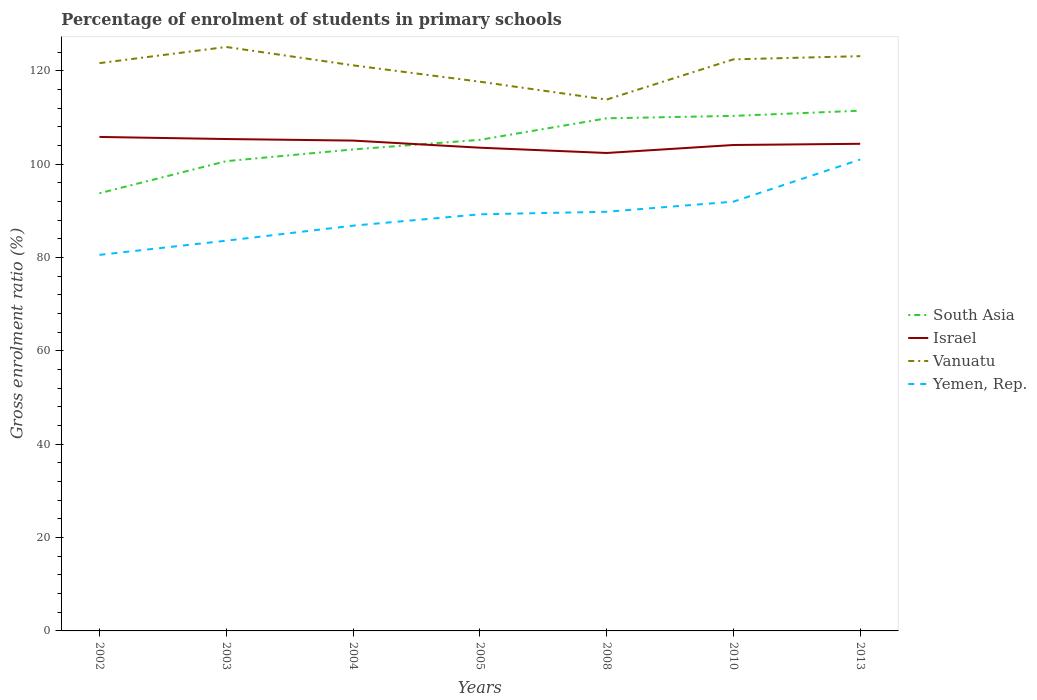Does the line corresponding to Yemen, Rep. intersect with the line corresponding to Israel?
Your answer should be very brief. No. Is the number of lines equal to the number of legend labels?
Your answer should be very brief. Yes. Across all years, what is the maximum percentage of students enrolled in primary schools in Israel?
Provide a short and direct response. 102.43. In which year was the percentage of students enrolled in primary schools in Yemen, Rep. maximum?
Ensure brevity in your answer.  2002. What is the total percentage of students enrolled in primary schools in Yemen, Rep. in the graph?
Provide a short and direct response. -9.03. What is the difference between the highest and the second highest percentage of students enrolled in primary schools in Israel?
Provide a short and direct response. 3.44. How many lines are there?
Keep it short and to the point. 4. What is the difference between two consecutive major ticks on the Y-axis?
Offer a very short reply. 20. Does the graph contain any zero values?
Offer a very short reply. No. Does the graph contain grids?
Provide a succinct answer. No. Where does the legend appear in the graph?
Keep it short and to the point. Center right. How many legend labels are there?
Your answer should be very brief. 4. How are the legend labels stacked?
Your answer should be very brief. Vertical. What is the title of the graph?
Ensure brevity in your answer.  Percentage of enrolment of students in primary schools. Does "Cameroon" appear as one of the legend labels in the graph?
Your response must be concise. No. What is the label or title of the Y-axis?
Keep it short and to the point. Gross enrolment ratio (%). What is the Gross enrolment ratio (%) of South Asia in 2002?
Give a very brief answer. 93.8. What is the Gross enrolment ratio (%) of Israel in 2002?
Offer a very short reply. 105.87. What is the Gross enrolment ratio (%) in Vanuatu in 2002?
Offer a very short reply. 121.68. What is the Gross enrolment ratio (%) of Yemen, Rep. in 2002?
Provide a succinct answer. 80.59. What is the Gross enrolment ratio (%) of South Asia in 2003?
Offer a very short reply. 100.68. What is the Gross enrolment ratio (%) in Israel in 2003?
Provide a short and direct response. 105.42. What is the Gross enrolment ratio (%) in Vanuatu in 2003?
Give a very brief answer. 125.15. What is the Gross enrolment ratio (%) of Yemen, Rep. in 2003?
Your response must be concise. 83.63. What is the Gross enrolment ratio (%) of South Asia in 2004?
Your answer should be very brief. 103.19. What is the Gross enrolment ratio (%) of Israel in 2004?
Provide a succinct answer. 105.09. What is the Gross enrolment ratio (%) of Vanuatu in 2004?
Provide a short and direct response. 121.22. What is the Gross enrolment ratio (%) in Yemen, Rep. in 2004?
Your answer should be very brief. 86.85. What is the Gross enrolment ratio (%) in South Asia in 2005?
Offer a terse response. 105.25. What is the Gross enrolment ratio (%) in Israel in 2005?
Offer a very short reply. 103.56. What is the Gross enrolment ratio (%) of Vanuatu in 2005?
Ensure brevity in your answer.  117.71. What is the Gross enrolment ratio (%) of Yemen, Rep. in 2005?
Provide a short and direct response. 89.29. What is the Gross enrolment ratio (%) of South Asia in 2008?
Provide a short and direct response. 109.86. What is the Gross enrolment ratio (%) in Israel in 2008?
Keep it short and to the point. 102.43. What is the Gross enrolment ratio (%) in Vanuatu in 2008?
Ensure brevity in your answer.  113.87. What is the Gross enrolment ratio (%) in Yemen, Rep. in 2008?
Your response must be concise. 89.83. What is the Gross enrolment ratio (%) of South Asia in 2010?
Offer a very short reply. 110.38. What is the Gross enrolment ratio (%) in Israel in 2010?
Offer a terse response. 104.14. What is the Gross enrolment ratio (%) of Vanuatu in 2010?
Your answer should be very brief. 122.49. What is the Gross enrolment ratio (%) of Yemen, Rep. in 2010?
Ensure brevity in your answer.  92. What is the Gross enrolment ratio (%) in South Asia in 2013?
Your response must be concise. 111.49. What is the Gross enrolment ratio (%) of Israel in 2013?
Provide a succinct answer. 104.4. What is the Gross enrolment ratio (%) of Vanuatu in 2013?
Give a very brief answer. 123.18. What is the Gross enrolment ratio (%) of Yemen, Rep. in 2013?
Give a very brief answer. 101.03. Across all years, what is the maximum Gross enrolment ratio (%) of South Asia?
Make the answer very short. 111.49. Across all years, what is the maximum Gross enrolment ratio (%) of Israel?
Your answer should be compact. 105.87. Across all years, what is the maximum Gross enrolment ratio (%) in Vanuatu?
Offer a very short reply. 125.15. Across all years, what is the maximum Gross enrolment ratio (%) of Yemen, Rep.?
Your response must be concise. 101.03. Across all years, what is the minimum Gross enrolment ratio (%) of South Asia?
Offer a terse response. 93.8. Across all years, what is the minimum Gross enrolment ratio (%) of Israel?
Provide a short and direct response. 102.43. Across all years, what is the minimum Gross enrolment ratio (%) of Vanuatu?
Offer a very short reply. 113.87. Across all years, what is the minimum Gross enrolment ratio (%) in Yemen, Rep.?
Provide a short and direct response. 80.59. What is the total Gross enrolment ratio (%) in South Asia in the graph?
Offer a very short reply. 734.64. What is the total Gross enrolment ratio (%) of Israel in the graph?
Your answer should be very brief. 730.9. What is the total Gross enrolment ratio (%) of Vanuatu in the graph?
Give a very brief answer. 845.3. What is the total Gross enrolment ratio (%) of Yemen, Rep. in the graph?
Keep it short and to the point. 623.21. What is the difference between the Gross enrolment ratio (%) of South Asia in 2002 and that in 2003?
Provide a succinct answer. -6.88. What is the difference between the Gross enrolment ratio (%) of Israel in 2002 and that in 2003?
Give a very brief answer. 0.45. What is the difference between the Gross enrolment ratio (%) of Vanuatu in 2002 and that in 2003?
Your answer should be compact. -3.46. What is the difference between the Gross enrolment ratio (%) in Yemen, Rep. in 2002 and that in 2003?
Your answer should be very brief. -3.04. What is the difference between the Gross enrolment ratio (%) in South Asia in 2002 and that in 2004?
Provide a short and direct response. -9.39. What is the difference between the Gross enrolment ratio (%) of Israel in 2002 and that in 2004?
Make the answer very short. 0.78. What is the difference between the Gross enrolment ratio (%) of Vanuatu in 2002 and that in 2004?
Your response must be concise. 0.47. What is the difference between the Gross enrolment ratio (%) in Yemen, Rep. in 2002 and that in 2004?
Make the answer very short. -6.26. What is the difference between the Gross enrolment ratio (%) of South Asia in 2002 and that in 2005?
Offer a terse response. -11.45. What is the difference between the Gross enrolment ratio (%) of Israel in 2002 and that in 2005?
Give a very brief answer. 2.3. What is the difference between the Gross enrolment ratio (%) of Vanuatu in 2002 and that in 2005?
Ensure brevity in your answer.  3.98. What is the difference between the Gross enrolment ratio (%) of Yemen, Rep. in 2002 and that in 2005?
Provide a succinct answer. -8.7. What is the difference between the Gross enrolment ratio (%) of South Asia in 2002 and that in 2008?
Ensure brevity in your answer.  -16.06. What is the difference between the Gross enrolment ratio (%) in Israel in 2002 and that in 2008?
Make the answer very short. 3.44. What is the difference between the Gross enrolment ratio (%) of Vanuatu in 2002 and that in 2008?
Make the answer very short. 7.81. What is the difference between the Gross enrolment ratio (%) of Yemen, Rep. in 2002 and that in 2008?
Make the answer very short. -9.24. What is the difference between the Gross enrolment ratio (%) in South Asia in 2002 and that in 2010?
Offer a terse response. -16.58. What is the difference between the Gross enrolment ratio (%) in Israel in 2002 and that in 2010?
Offer a very short reply. 1.73. What is the difference between the Gross enrolment ratio (%) of Vanuatu in 2002 and that in 2010?
Ensure brevity in your answer.  -0.81. What is the difference between the Gross enrolment ratio (%) of Yemen, Rep. in 2002 and that in 2010?
Your answer should be compact. -11.4. What is the difference between the Gross enrolment ratio (%) in South Asia in 2002 and that in 2013?
Ensure brevity in your answer.  -17.69. What is the difference between the Gross enrolment ratio (%) in Israel in 2002 and that in 2013?
Provide a short and direct response. 1.47. What is the difference between the Gross enrolment ratio (%) of Vanuatu in 2002 and that in 2013?
Make the answer very short. -1.5. What is the difference between the Gross enrolment ratio (%) of Yemen, Rep. in 2002 and that in 2013?
Offer a terse response. -20.44. What is the difference between the Gross enrolment ratio (%) in South Asia in 2003 and that in 2004?
Your answer should be compact. -2.52. What is the difference between the Gross enrolment ratio (%) in Israel in 2003 and that in 2004?
Keep it short and to the point. 0.33. What is the difference between the Gross enrolment ratio (%) in Vanuatu in 2003 and that in 2004?
Offer a terse response. 3.93. What is the difference between the Gross enrolment ratio (%) in Yemen, Rep. in 2003 and that in 2004?
Offer a very short reply. -3.22. What is the difference between the Gross enrolment ratio (%) in South Asia in 2003 and that in 2005?
Make the answer very short. -4.57. What is the difference between the Gross enrolment ratio (%) in Israel in 2003 and that in 2005?
Offer a terse response. 1.85. What is the difference between the Gross enrolment ratio (%) in Vanuatu in 2003 and that in 2005?
Give a very brief answer. 7.44. What is the difference between the Gross enrolment ratio (%) of Yemen, Rep. in 2003 and that in 2005?
Ensure brevity in your answer.  -5.66. What is the difference between the Gross enrolment ratio (%) of South Asia in 2003 and that in 2008?
Ensure brevity in your answer.  -9.18. What is the difference between the Gross enrolment ratio (%) of Israel in 2003 and that in 2008?
Your response must be concise. 2.99. What is the difference between the Gross enrolment ratio (%) in Vanuatu in 2003 and that in 2008?
Your response must be concise. 11.27. What is the difference between the Gross enrolment ratio (%) in Yemen, Rep. in 2003 and that in 2008?
Offer a terse response. -6.2. What is the difference between the Gross enrolment ratio (%) in South Asia in 2003 and that in 2010?
Your answer should be compact. -9.71. What is the difference between the Gross enrolment ratio (%) of Israel in 2003 and that in 2010?
Your response must be concise. 1.28. What is the difference between the Gross enrolment ratio (%) in Vanuatu in 2003 and that in 2010?
Give a very brief answer. 2.65. What is the difference between the Gross enrolment ratio (%) of Yemen, Rep. in 2003 and that in 2010?
Offer a terse response. -8.36. What is the difference between the Gross enrolment ratio (%) of South Asia in 2003 and that in 2013?
Give a very brief answer. -10.82. What is the difference between the Gross enrolment ratio (%) of Israel in 2003 and that in 2013?
Your answer should be very brief. 1.02. What is the difference between the Gross enrolment ratio (%) of Vanuatu in 2003 and that in 2013?
Provide a short and direct response. 1.97. What is the difference between the Gross enrolment ratio (%) of Yemen, Rep. in 2003 and that in 2013?
Keep it short and to the point. -17.4. What is the difference between the Gross enrolment ratio (%) of South Asia in 2004 and that in 2005?
Your response must be concise. -2.05. What is the difference between the Gross enrolment ratio (%) of Israel in 2004 and that in 2005?
Provide a succinct answer. 1.52. What is the difference between the Gross enrolment ratio (%) of Vanuatu in 2004 and that in 2005?
Provide a short and direct response. 3.51. What is the difference between the Gross enrolment ratio (%) of Yemen, Rep. in 2004 and that in 2005?
Give a very brief answer. -2.44. What is the difference between the Gross enrolment ratio (%) of South Asia in 2004 and that in 2008?
Provide a succinct answer. -6.67. What is the difference between the Gross enrolment ratio (%) in Israel in 2004 and that in 2008?
Your answer should be very brief. 2.66. What is the difference between the Gross enrolment ratio (%) in Vanuatu in 2004 and that in 2008?
Give a very brief answer. 7.34. What is the difference between the Gross enrolment ratio (%) of Yemen, Rep. in 2004 and that in 2008?
Ensure brevity in your answer.  -2.98. What is the difference between the Gross enrolment ratio (%) in South Asia in 2004 and that in 2010?
Keep it short and to the point. -7.19. What is the difference between the Gross enrolment ratio (%) of Israel in 2004 and that in 2010?
Your answer should be compact. 0.95. What is the difference between the Gross enrolment ratio (%) of Vanuatu in 2004 and that in 2010?
Ensure brevity in your answer.  -1.28. What is the difference between the Gross enrolment ratio (%) in Yemen, Rep. in 2004 and that in 2010?
Provide a succinct answer. -5.15. What is the difference between the Gross enrolment ratio (%) in South Asia in 2004 and that in 2013?
Offer a very short reply. -8.3. What is the difference between the Gross enrolment ratio (%) of Israel in 2004 and that in 2013?
Make the answer very short. 0.69. What is the difference between the Gross enrolment ratio (%) of Vanuatu in 2004 and that in 2013?
Your answer should be compact. -1.96. What is the difference between the Gross enrolment ratio (%) of Yemen, Rep. in 2004 and that in 2013?
Provide a succinct answer. -14.18. What is the difference between the Gross enrolment ratio (%) in South Asia in 2005 and that in 2008?
Your answer should be compact. -4.61. What is the difference between the Gross enrolment ratio (%) in Israel in 2005 and that in 2008?
Give a very brief answer. 1.14. What is the difference between the Gross enrolment ratio (%) of Vanuatu in 2005 and that in 2008?
Provide a succinct answer. 3.83. What is the difference between the Gross enrolment ratio (%) of Yemen, Rep. in 2005 and that in 2008?
Provide a succinct answer. -0.54. What is the difference between the Gross enrolment ratio (%) in South Asia in 2005 and that in 2010?
Your answer should be very brief. -5.14. What is the difference between the Gross enrolment ratio (%) of Israel in 2005 and that in 2010?
Your answer should be very brief. -0.57. What is the difference between the Gross enrolment ratio (%) in Vanuatu in 2005 and that in 2010?
Offer a very short reply. -4.79. What is the difference between the Gross enrolment ratio (%) of Yemen, Rep. in 2005 and that in 2010?
Your answer should be compact. -2.71. What is the difference between the Gross enrolment ratio (%) of South Asia in 2005 and that in 2013?
Provide a succinct answer. -6.25. What is the difference between the Gross enrolment ratio (%) of Israel in 2005 and that in 2013?
Offer a terse response. -0.83. What is the difference between the Gross enrolment ratio (%) in Vanuatu in 2005 and that in 2013?
Provide a succinct answer. -5.47. What is the difference between the Gross enrolment ratio (%) in Yemen, Rep. in 2005 and that in 2013?
Your response must be concise. -11.74. What is the difference between the Gross enrolment ratio (%) in South Asia in 2008 and that in 2010?
Provide a succinct answer. -0.52. What is the difference between the Gross enrolment ratio (%) of Israel in 2008 and that in 2010?
Provide a short and direct response. -1.71. What is the difference between the Gross enrolment ratio (%) of Vanuatu in 2008 and that in 2010?
Provide a succinct answer. -8.62. What is the difference between the Gross enrolment ratio (%) of Yemen, Rep. in 2008 and that in 2010?
Provide a short and direct response. -2.17. What is the difference between the Gross enrolment ratio (%) of South Asia in 2008 and that in 2013?
Provide a short and direct response. -1.63. What is the difference between the Gross enrolment ratio (%) of Israel in 2008 and that in 2013?
Offer a terse response. -1.97. What is the difference between the Gross enrolment ratio (%) in Vanuatu in 2008 and that in 2013?
Your answer should be compact. -9.31. What is the difference between the Gross enrolment ratio (%) of Yemen, Rep. in 2008 and that in 2013?
Provide a succinct answer. -11.2. What is the difference between the Gross enrolment ratio (%) of South Asia in 2010 and that in 2013?
Make the answer very short. -1.11. What is the difference between the Gross enrolment ratio (%) of Israel in 2010 and that in 2013?
Offer a terse response. -0.26. What is the difference between the Gross enrolment ratio (%) in Vanuatu in 2010 and that in 2013?
Provide a short and direct response. -0.69. What is the difference between the Gross enrolment ratio (%) of Yemen, Rep. in 2010 and that in 2013?
Ensure brevity in your answer.  -9.03. What is the difference between the Gross enrolment ratio (%) in South Asia in 2002 and the Gross enrolment ratio (%) in Israel in 2003?
Offer a very short reply. -11.62. What is the difference between the Gross enrolment ratio (%) of South Asia in 2002 and the Gross enrolment ratio (%) of Vanuatu in 2003?
Provide a short and direct response. -31.35. What is the difference between the Gross enrolment ratio (%) of South Asia in 2002 and the Gross enrolment ratio (%) of Yemen, Rep. in 2003?
Your response must be concise. 10.17. What is the difference between the Gross enrolment ratio (%) in Israel in 2002 and the Gross enrolment ratio (%) in Vanuatu in 2003?
Offer a terse response. -19.28. What is the difference between the Gross enrolment ratio (%) of Israel in 2002 and the Gross enrolment ratio (%) of Yemen, Rep. in 2003?
Provide a short and direct response. 22.24. What is the difference between the Gross enrolment ratio (%) in Vanuatu in 2002 and the Gross enrolment ratio (%) in Yemen, Rep. in 2003?
Make the answer very short. 38.05. What is the difference between the Gross enrolment ratio (%) of South Asia in 2002 and the Gross enrolment ratio (%) of Israel in 2004?
Your response must be concise. -11.29. What is the difference between the Gross enrolment ratio (%) of South Asia in 2002 and the Gross enrolment ratio (%) of Vanuatu in 2004?
Give a very brief answer. -27.42. What is the difference between the Gross enrolment ratio (%) of South Asia in 2002 and the Gross enrolment ratio (%) of Yemen, Rep. in 2004?
Offer a terse response. 6.95. What is the difference between the Gross enrolment ratio (%) of Israel in 2002 and the Gross enrolment ratio (%) of Vanuatu in 2004?
Offer a very short reply. -15.35. What is the difference between the Gross enrolment ratio (%) of Israel in 2002 and the Gross enrolment ratio (%) of Yemen, Rep. in 2004?
Your response must be concise. 19.02. What is the difference between the Gross enrolment ratio (%) in Vanuatu in 2002 and the Gross enrolment ratio (%) in Yemen, Rep. in 2004?
Your answer should be compact. 34.83. What is the difference between the Gross enrolment ratio (%) of South Asia in 2002 and the Gross enrolment ratio (%) of Israel in 2005?
Provide a succinct answer. -9.77. What is the difference between the Gross enrolment ratio (%) of South Asia in 2002 and the Gross enrolment ratio (%) of Vanuatu in 2005?
Provide a succinct answer. -23.91. What is the difference between the Gross enrolment ratio (%) in South Asia in 2002 and the Gross enrolment ratio (%) in Yemen, Rep. in 2005?
Offer a very short reply. 4.51. What is the difference between the Gross enrolment ratio (%) in Israel in 2002 and the Gross enrolment ratio (%) in Vanuatu in 2005?
Provide a short and direct response. -11.84. What is the difference between the Gross enrolment ratio (%) in Israel in 2002 and the Gross enrolment ratio (%) in Yemen, Rep. in 2005?
Your answer should be compact. 16.58. What is the difference between the Gross enrolment ratio (%) in Vanuatu in 2002 and the Gross enrolment ratio (%) in Yemen, Rep. in 2005?
Offer a very short reply. 32.4. What is the difference between the Gross enrolment ratio (%) in South Asia in 2002 and the Gross enrolment ratio (%) in Israel in 2008?
Ensure brevity in your answer.  -8.63. What is the difference between the Gross enrolment ratio (%) in South Asia in 2002 and the Gross enrolment ratio (%) in Vanuatu in 2008?
Offer a terse response. -20.08. What is the difference between the Gross enrolment ratio (%) of South Asia in 2002 and the Gross enrolment ratio (%) of Yemen, Rep. in 2008?
Offer a terse response. 3.97. What is the difference between the Gross enrolment ratio (%) of Israel in 2002 and the Gross enrolment ratio (%) of Vanuatu in 2008?
Offer a terse response. -8.01. What is the difference between the Gross enrolment ratio (%) of Israel in 2002 and the Gross enrolment ratio (%) of Yemen, Rep. in 2008?
Your response must be concise. 16.04. What is the difference between the Gross enrolment ratio (%) in Vanuatu in 2002 and the Gross enrolment ratio (%) in Yemen, Rep. in 2008?
Offer a terse response. 31.85. What is the difference between the Gross enrolment ratio (%) of South Asia in 2002 and the Gross enrolment ratio (%) of Israel in 2010?
Offer a very short reply. -10.34. What is the difference between the Gross enrolment ratio (%) in South Asia in 2002 and the Gross enrolment ratio (%) in Vanuatu in 2010?
Make the answer very short. -28.69. What is the difference between the Gross enrolment ratio (%) in South Asia in 2002 and the Gross enrolment ratio (%) in Yemen, Rep. in 2010?
Provide a short and direct response. 1.8. What is the difference between the Gross enrolment ratio (%) in Israel in 2002 and the Gross enrolment ratio (%) in Vanuatu in 2010?
Your response must be concise. -16.62. What is the difference between the Gross enrolment ratio (%) in Israel in 2002 and the Gross enrolment ratio (%) in Yemen, Rep. in 2010?
Make the answer very short. 13.87. What is the difference between the Gross enrolment ratio (%) of Vanuatu in 2002 and the Gross enrolment ratio (%) of Yemen, Rep. in 2010?
Give a very brief answer. 29.69. What is the difference between the Gross enrolment ratio (%) of South Asia in 2002 and the Gross enrolment ratio (%) of Israel in 2013?
Make the answer very short. -10.6. What is the difference between the Gross enrolment ratio (%) of South Asia in 2002 and the Gross enrolment ratio (%) of Vanuatu in 2013?
Offer a terse response. -29.38. What is the difference between the Gross enrolment ratio (%) in South Asia in 2002 and the Gross enrolment ratio (%) in Yemen, Rep. in 2013?
Keep it short and to the point. -7.23. What is the difference between the Gross enrolment ratio (%) in Israel in 2002 and the Gross enrolment ratio (%) in Vanuatu in 2013?
Offer a very short reply. -17.31. What is the difference between the Gross enrolment ratio (%) of Israel in 2002 and the Gross enrolment ratio (%) of Yemen, Rep. in 2013?
Give a very brief answer. 4.84. What is the difference between the Gross enrolment ratio (%) of Vanuatu in 2002 and the Gross enrolment ratio (%) of Yemen, Rep. in 2013?
Provide a succinct answer. 20.66. What is the difference between the Gross enrolment ratio (%) of South Asia in 2003 and the Gross enrolment ratio (%) of Israel in 2004?
Your answer should be compact. -4.41. What is the difference between the Gross enrolment ratio (%) in South Asia in 2003 and the Gross enrolment ratio (%) in Vanuatu in 2004?
Offer a very short reply. -20.54. What is the difference between the Gross enrolment ratio (%) of South Asia in 2003 and the Gross enrolment ratio (%) of Yemen, Rep. in 2004?
Provide a succinct answer. 13.83. What is the difference between the Gross enrolment ratio (%) in Israel in 2003 and the Gross enrolment ratio (%) in Vanuatu in 2004?
Make the answer very short. -15.8. What is the difference between the Gross enrolment ratio (%) of Israel in 2003 and the Gross enrolment ratio (%) of Yemen, Rep. in 2004?
Offer a very short reply. 18.57. What is the difference between the Gross enrolment ratio (%) in Vanuatu in 2003 and the Gross enrolment ratio (%) in Yemen, Rep. in 2004?
Make the answer very short. 38.3. What is the difference between the Gross enrolment ratio (%) of South Asia in 2003 and the Gross enrolment ratio (%) of Israel in 2005?
Ensure brevity in your answer.  -2.89. What is the difference between the Gross enrolment ratio (%) in South Asia in 2003 and the Gross enrolment ratio (%) in Vanuatu in 2005?
Provide a succinct answer. -17.03. What is the difference between the Gross enrolment ratio (%) in South Asia in 2003 and the Gross enrolment ratio (%) in Yemen, Rep. in 2005?
Make the answer very short. 11.39. What is the difference between the Gross enrolment ratio (%) in Israel in 2003 and the Gross enrolment ratio (%) in Vanuatu in 2005?
Make the answer very short. -12.29. What is the difference between the Gross enrolment ratio (%) in Israel in 2003 and the Gross enrolment ratio (%) in Yemen, Rep. in 2005?
Your answer should be compact. 16.13. What is the difference between the Gross enrolment ratio (%) of Vanuatu in 2003 and the Gross enrolment ratio (%) of Yemen, Rep. in 2005?
Offer a terse response. 35.86. What is the difference between the Gross enrolment ratio (%) of South Asia in 2003 and the Gross enrolment ratio (%) of Israel in 2008?
Your answer should be compact. -1.75. What is the difference between the Gross enrolment ratio (%) of South Asia in 2003 and the Gross enrolment ratio (%) of Vanuatu in 2008?
Your answer should be compact. -13.2. What is the difference between the Gross enrolment ratio (%) in South Asia in 2003 and the Gross enrolment ratio (%) in Yemen, Rep. in 2008?
Provide a succinct answer. 10.85. What is the difference between the Gross enrolment ratio (%) of Israel in 2003 and the Gross enrolment ratio (%) of Vanuatu in 2008?
Your answer should be compact. -8.46. What is the difference between the Gross enrolment ratio (%) of Israel in 2003 and the Gross enrolment ratio (%) of Yemen, Rep. in 2008?
Offer a terse response. 15.59. What is the difference between the Gross enrolment ratio (%) of Vanuatu in 2003 and the Gross enrolment ratio (%) of Yemen, Rep. in 2008?
Your answer should be compact. 35.32. What is the difference between the Gross enrolment ratio (%) of South Asia in 2003 and the Gross enrolment ratio (%) of Israel in 2010?
Offer a very short reply. -3.46. What is the difference between the Gross enrolment ratio (%) in South Asia in 2003 and the Gross enrolment ratio (%) in Vanuatu in 2010?
Your response must be concise. -21.82. What is the difference between the Gross enrolment ratio (%) of South Asia in 2003 and the Gross enrolment ratio (%) of Yemen, Rep. in 2010?
Your response must be concise. 8.68. What is the difference between the Gross enrolment ratio (%) of Israel in 2003 and the Gross enrolment ratio (%) of Vanuatu in 2010?
Your response must be concise. -17.08. What is the difference between the Gross enrolment ratio (%) in Israel in 2003 and the Gross enrolment ratio (%) in Yemen, Rep. in 2010?
Ensure brevity in your answer.  13.42. What is the difference between the Gross enrolment ratio (%) of Vanuatu in 2003 and the Gross enrolment ratio (%) of Yemen, Rep. in 2010?
Keep it short and to the point. 33.15. What is the difference between the Gross enrolment ratio (%) of South Asia in 2003 and the Gross enrolment ratio (%) of Israel in 2013?
Make the answer very short. -3.72. What is the difference between the Gross enrolment ratio (%) of South Asia in 2003 and the Gross enrolment ratio (%) of Vanuatu in 2013?
Make the answer very short. -22.5. What is the difference between the Gross enrolment ratio (%) of South Asia in 2003 and the Gross enrolment ratio (%) of Yemen, Rep. in 2013?
Your response must be concise. -0.35. What is the difference between the Gross enrolment ratio (%) of Israel in 2003 and the Gross enrolment ratio (%) of Vanuatu in 2013?
Make the answer very short. -17.76. What is the difference between the Gross enrolment ratio (%) in Israel in 2003 and the Gross enrolment ratio (%) in Yemen, Rep. in 2013?
Offer a terse response. 4.39. What is the difference between the Gross enrolment ratio (%) of Vanuatu in 2003 and the Gross enrolment ratio (%) of Yemen, Rep. in 2013?
Your answer should be compact. 24.12. What is the difference between the Gross enrolment ratio (%) in South Asia in 2004 and the Gross enrolment ratio (%) in Israel in 2005?
Provide a succinct answer. -0.37. What is the difference between the Gross enrolment ratio (%) of South Asia in 2004 and the Gross enrolment ratio (%) of Vanuatu in 2005?
Provide a short and direct response. -14.52. What is the difference between the Gross enrolment ratio (%) of South Asia in 2004 and the Gross enrolment ratio (%) of Yemen, Rep. in 2005?
Keep it short and to the point. 13.9. What is the difference between the Gross enrolment ratio (%) in Israel in 2004 and the Gross enrolment ratio (%) in Vanuatu in 2005?
Ensure brevity in your answer.  -12.62. What is the difference between the Gross enrolment ratio (%) of Israel in 2004 and the Gross enrolment ratio (%) of Yemen, Rep. in 2005?
Make the answer very short. 15.8. What is the difference between the Gross enrolment ratio (%) of Vanuatu in 2004 and the Gross enrolment ratio (%) of Yemen, Rep. in 2005?
Provide a succinct answer. 31.93. What is the difference between the Gross enrolment ratio (%) in South Asia in 2004 and the Gross enrolment ratio (%) in Israel in 2008?
Give a very brief answer. 0.76. What is the difference between the Gross enrolment ratio (%) in South Asia in 2004 and the Gross enrolment ratio (%) in Vanuatu in 2008?
Offer a terse response. -10.68. What is the difference between the Gross enrolment ratio (%) in South Asia in 2004 and the Gross enrolment ratio (%) in Yemen, Rep. in 2008?
Make the answer very short. 13.36. What is the difference between the Gross enrolment ratio (%) in Israel in 2004 and the Gross enrolment ratio (%) in Vanuatu in 2008?
Your answer should be compact. -8.79. What is the difference between the Gross enrolment ratio (%) in Israel in 2004 and the Gross enrolment ratio (%) in Yemen, Rep. in 2008?
Your answer should be very brief. 15.26. What is the difference between the Gross enrolment ratio (%) of Vanuatu in 2004 and the Gross enrolment ratio (%) of Yemen, Rep. in 2008?
Make the answer very short. 31.39. What is the difference between the Gross enrolment ratio (%) in South Asia in 2004 and the Gross enrolment ratio (%) in Israel in 2010?
Offer a terse response. -0.95. What is the difference between the Gross enrolment ratio (%) in South Asia in 2004 and the Gross enrolment ratio (%) in Vanuatu in 2010?
Ensure brevity in your answer.  -19.3. What is the difference between the Gross enrolment ratio (%) of South Asia in 2004 and the Gross enrolment ratio (%) of Yemen, Rep. in 2010?
Offer a terse response. 11.2. What is the difference between the Gross enrolment ratio (%) of Israel in 2004 and the Gross enrolment ratio (%) of Vanuatu in 2010?
Your answer should be compact. -17.41. What is the difference between the Gross enrolment ratio (%) in Israel in 2004 and the Gross enrolment ratio (%) in Yemen, Rep. in 2010?
Make the answer very short. 13.09. What is the difference between the Gross enrolment ratio (%) of Vanuatu in 2004 and the Gross enrolment ratio (%) of Yemen, Rep. in 2010?
Make the answer very short. 29.22. What is the difference between the Gross enrolment ratio (%) in South Asia in 2004 and the Gross enrolment ratio (%) in Israel in 2013?
Give a very brief answer. -1.21. What is the difference between the Gross enrolment ratio (%) in South Asia in 2004 and the Gross enrolment ratio (%) in Vanuatu in 2013?
Your answer should be compact. -19.99. What is the difference between the Gross enrolment ratio (%) in South Asia in 2004 and the Gross enrolment ratio (%) in Yemen, Rep. in 2013?
Keep it short and to the point. 2.16. What is the difference between the Gross enrolment ratio (%) of Israel in 2004 and the Gross enrolment ratio (%) of Vanuatu in 2013?
Keep it short and to the point. -18.09. What is the difference between the Gross enrolment ratio (%) of Israel in 2004 and the Gross enrolment ratio (%) of Yemen, Rep. in 2013?
Make the answer very short. 4.06. What is the difference between the Gross enrolment ratio (%) of Vanuatu in 2004 and the Gross enrolment ratio (%) of Yemen, Rep. in 2013?
Give a very brief answer. 20.19. What is the difference between the Gross enrolment ratio (%) in South Asia in 2005 and the Gross enrolment ratio (%) in Israel in 2008?
Offer a terse response. 2.82. What is the difference between the Gross enrolment ratio (%) in South Asia in 2005 and the Gross enrolment ratio (%) in Vanuatu in 2008?
Make the answer very short. -8.63. What is the difference between the Gross enrolment ratio (%) of South Asia in 2005 and the Gross enrolment ratio (%) of Yemen, Rep. in 2008?
Your answer should be compact. 15.42. What is the difference between the Gross enrolment ratio (%) of Israel in 2005 and the Gross enrolment ratio (%) of Vanuatu in 2008?
Make the answer very short. -10.31. What is the difference between the Gross enrolment ratio (%) in Israel in 2005 and the Gross enrolment ratio (%) in Yemen, Rep. in 2008?
Provide a short and direct response. 13.73. What is the difference between the Gross enrolment ratio (%) in Vanuatu in 2005 and the Gross enrolment ratio (%) in Yemen, Rep. in 2008?
Offer a very short reply. 27.88. What is the difference between the Gross enrolment ratio (%) of South Asia in 2005 and the Gross enrolment ratio (%) of Israel in 2010?
Your answer should be very brief. 1.11. What is the difference between the Gross enrolment ratio (%) in South Asia in 2005 and the Gross enrolment ratio (%) in Vanuatu in 2010?
Your response must be concise. -17.25. What is the difference between the Gross enrolment ratio (%) of South Asia in 2005 and the Gross enrolment ratio (%) of Yemen, Rep. in 2010?
Your response must be concise. 13.25. What is the difference between the Gross enrolment ratio (%) of Israel in 2005 and the Gross enrolment ratio (%) of Vanuatu in 2010?
Make the answer very short. -18.93. What is the difference between the Gross enrolment ratio (%) of Israel in 2005 and the Gross enrolment ratio (%) of Yemen, Rep. in 2010?
Give a very brief answer. 11.57. What is the difference between the Gross enrolment ratio (%) of Vanuatu in 2005 and the Gross enrolment ratio (%) of Yemen, Rep. in 2010?
Give a very brief answer. 25.71. What is the difference between the Gross enrolment ratio (%) of South Asia in 2005 and the Gross enrolment ratio (%) of Israel in 2013?
Your answer should be compact. 0.85. What is the difference between the Gross enrolment ratio (%) in South Asia in 2005 and the Gross enrolment ratio (%) in Vanuatu in 2013?
Make the answer very short. -17.93. What is the difference between the Gross enrolment ratio (%) in South Asia in 2005 and the Gross enrolment ratio (%) in Yemen, Rep. in 2013?
Offer a terse response. 4.22. What is the difference between the Gross enrolment ratio (%) of Israel in 2005 and the Gross enrolment ratio (%) of Vanuatu in 2013?
Ensure brevity in your answer.  -19.62. What is the difference between the Gross enrolment ratio (%) of Israel in 2005 and the Gross enrolment ratio (%) of Yemen, Rep. in 2013?
Offer a very short reply. 2.54. What is the difference between the Gross enrolment ratio (%) of Vanuatu in 2005 and the Gross enrolment ratio (%) of Yemen, Rep. in 2013?
Give a very brief answer. 16.68. What is the difference between the Gross enrolment ratio (%) in South Asia in 2008 and the Gross enrolment ratio (%) in Israel in 2010?
Keep it short and to the point. 5.72. What is the difference between the Gross enrolment ratio (%) in South Asia in 2008 and the Gross enrolment ratio (%) in Vanuatu in 2010?
Your answer should be compact. -12.64. What is the difference between the Gross enrolment ratio (%) in South Asia in 2008 and the Gross enrolment ratio (%) in Yemen, Rep. in 2010?
Your answer should be very brief. 17.86. What is the difference between the Gross enrolment ratio (%) of Israel in 2008 and the Gross enrolment ratio (%) of Vanuatu in 2010?
Make the answer very short. -20.07. What is the difference between the Gross enrolment ratio (%) in Israel in 2008 and the Gross enrolment ratio (%) in Yemen, Rep. in 2010?
Your answer should be compact. 10.43. What is the difference between the Gross enrolment ratio (%) of Vanuatu in 2008 and the Gross enrolment ratio (%) of Yemen, Rep. in 2010?
Provide a short and direct response. 21.88. What is the difference between the Gross enrolment ratio (%) of South Asia in 2008 and the Gross enrolment ratio (%) of Israel in 2013?
Give a very brief answer. 5.46. What is the difference between the Gross enrolment ratio (%) in South Asia in 2008 and the Gross enrolment ratio (%) in Vanuatu in 2013?
Provide a short and direct response. -13.32. What is the difference between the Gross enrolment ratio (%) in South Asia in 2008 and the Gross enrolment ratio (%) in Yemen, Rep. in 2013?
Give a very brief answer. 8.83. What is the difference between the Gross enrolment ratio (%) in Israel in 2008 and the Gross enrolment ratio (%) in Vanuatu in 2013?
Offer a very short reply. -20.75. What is the difference between the Gross enrolment ratio (%) in Israel in 2008 and the Gross enrolment ratio (%) in Yemen, Rep. in 2013?
Make the answer very short. 1.4. What is the difference between the Gross enrolment ratio (%) in Vanuatu in 2008 and the Gross enrolment ratio (%) in Yemen, Rep. in 2013?
Offer a very short reply. 12.85. What is the difference between the Gross enrolment ratio (%) in South Asia in 2010 and the Gross enrolment ratio (%) in Israel in 2013?
Make the answer very short. 5.98. What is the difference between the Gross enrolment ratio (%) in South Asia in 2010 and the Gross enrolment ratio (%) in Vanuatu in 2013?
Your response must be concise. -12.8. What is the difference between the Gross enrolment ratio (%) in South Asia in 2010 and the Gross enrolment ratio (%) in Yemen, Rep. in 2013?
Provide a short and direct response. 9.35. What is the difference between the Gross enrolment ratio (%) in Israel in 2010 and the Gross enrolment ratio (%) in Vanuatu in 2013?
Your response must be concise. -19.04. What is the difference between the Gross enrolment ratio (%) in Israel in 2010 and the Gross enrolment ratio (%) in Yemen, Rep. in 2013?
Keep it short and to the point. 3.11. What is the difference between the Gross enrolment ratio (%) in Vanuatu in 2010 and the Gross enrolment ratio (%) in Yemen, Rep. in 2013?
Make the answer very short. 21.47. What is the average Gross enrolment ratio (%) in South Asia per year?
Provide a succinct answer. 104.95. What is the average Gross enrolment ratio (%) of Israel per year?
Make the answer very short. 104.41. What is the average Gross enrolment ratio (%) of Vanuatu per year?
Offer a terse response. 120.76. What is the average Gross enrolment ratio (%) in Yemen, Rep. per year?
Your answer should be very brief. 89.03. In the year 2002, what is the difference between the Gross enrolment ratio (%) in South Asia and Gross enrolment ratio (%) in Israel?
Ensure brevity in your answer.  -12.07. In the year 2002, what is the difference between the Gross enrolment ratio (%) in South Asia and Gross enrolment ratio (%) in Vanuatu?
Your answer should be very brief. -27.88. In the year 2002, what is the difference between the Gross enrolment ratio (%) of South Asia and Gross enrolment ratio (%) of Yemen, Rep.?
Your answer should be compact. 13.21. In the year 2002, what is the difference between the Gross enrolment ratio (%) in Israel and Gross enrolment ratio (%) in Vanuatu?
Provide a short and direct response. -15.81. In the year 2002, what is the difference between the Gross enrolment ratio (%) of Israel and Gross enrolment ratio (%) of Yemen, Rep.?
Give a very brief answer. 25.28. In the year 2002, what is the difference between the Gross enrolment ratio (%) in Vanuatu and Gross enrolment ratio (%) in Yemen, Rep.?
Provide a succinct answer. 41.09. In the year 2003, what is the difference between the Gross enrolment ratio (%) in South Asia and Gross enrolment ratio (%) in Israel?
Provide a short and direct response. -4.74. In the year 2003, what is the difference between the Gross enrolment ratio (%) in South Asia and Gross enrolment ratio (%) in Vanuatu?
Give a very brief answer. -24.47. In the year 2003, what is the difference between the Gross enrolment ratio (%) of South Asia and Gross enrolment ratio (%) of Yemen, Rep.?
Ensure brevity in your answer.  17.04. In the year 2003, what is the difference between the Gross enrolment ratio (%) in Israel and Gross enrolment ratio (%) in Vanuatu?
Give a very brief answer. -19.73. In the year 2003, what is the difference between the Gross enrolment ratio (%) of Israel and Gross enrolment ratio (%) of Yemen, Rep.?
Give a very brief answer. 21.79. In the year 2003, what is the difference between the Gross enrolment ratio (%) of Vanuatu and Gross enrolment ratio (%) of Yemen, Rep.?
Keep it short and to the point. 41.52. In the year 2004, what is the difference between the Gross enrolment ratio (%) in South Asia and Gross enrolment ratio (%) in Israel?
Keep it short and to the point. -1.9. In the year 2004, what is the difference between the Gross enrolment ratio (%) of South Asia and Gross enrolment ratio (%) of Vanuatu?
Provide a short and direct response. -18.02. In the year 2004, what is the difference between the Gross enrolment ratio (%) of South Asia and Gross enrolment ratio (%) of Yemen, Rep.?
Your answer should be compact. 16.34. In the year 2004, what is the difference between the Gross enrolment ratio (%) in Israel and Gross enrolment ratio (%) in Vanuatu?
Your response must be concise. -16.13. In the year 2004, what is the difference between the Gross enrolment ratio (%) of Israel and Gross enrolment ratio (%) of Yemen, Rep.?
Ensure brevity in your answer.  18.24. In the year 2004, what is the difference between the Gross enrolment ratio (%) in Vanuatu and Gross enrolment ratio (%) in Yemen, Rep.?
Provide a succinct answer. 34.37. In the year 2005, what is the difference between the Gross enrolment ratio (%) in South Asia and Gross enrolment ratio (%) in Israel?
Provide a short and direct response. 1.68. In the year 2005, what is the difference between the Gross enrolment ratio (%) in South Asia and Gross enrolment ratio (%) in Vanuatu?
Provide a short and direct response. -12.46. In the year 2005, what is the difference between the Gross enrolment ratio (%) of South Asia and Gross enrolment ratio (%) of Yemen, Rep.?
Offer a terse response. 15.96. In the year 2005, what is the difference between the Gross enrolment ratio (%) of Israel and Gross enrolment ratio (%) of Vanuatu?
Your answer should be very brief. -14.14. In the year 2005, what is the difference between the Gross enrolment ratio (%) of Israel and Gross enrolment ratio (%) of Yemen, Rep.?
Keep it short and to the point. 14.28. In the year 2005, what is the difference between the Gross enrolment ratio (%) of Vanuatu and Gross enrolment ratio (%) of Yemen, Rep.?
Your response must be concise. 28.42. In the year 2008, what is the difference between the Gross enrolment ratio (%) of South Asia and Gross enrolment ratio (%) of Israel?
Offer a very short reply. 7.43. In the year 2008, what is the difference between the Gross enrolment ratio (%) of South Asia and Gross enrolment ratio (%) of Vanuatu?
Give a very brief answer. -4.02. In the year 2008, what is the difference between the Gross enrolment ratio (%) of South Asia and Gross enrolment ratio (%) of Yemen, Rep.?
Make the answer very short. 20.03. In the year 2008, what is the difference between the Gross enrolment ratio (%) of Israel and Gross enrolment ratio (%) of Vanuatu?
Give a very brief answer. -11.45. In the year 2008, what is the difference between the Gross enrolment ratio (%) of Israel and Gross enrolment ratio (%) of Yemen, Rep.?
Keep it short and to the point. 12.6. In the year 2008, what is the difference between the Gross enrolment ratio (%) of Vanuatu and Gross enrolment ratio (%) of Yemen, Rep.?
Ensure brevity in your answer.  24.04. In the year 2010, what is the difference between the Gross enrolment ratio (%) of South Asia and Gross enrolment ratio (%) of Israel?
Your response must be concise. 6.24. In the year 2010, what is the difference between the Gross enrolment ratio (%) in South Asia and Gross enrolment ratio (%) in Vanuatu?
Your answer should be compact. -12.11. In the year 2010, what is the difference between the Gross enrolment ratio (%) in South Asia and Gross enrolment ratio (%) in Yemen, Rep.?
Your answer should be compact. 18.39. In the year 2010, what is the difference between the Gross enrolment ratio (%) in Israel and Gross enrolment ratio (%) in Vanuatu?
Your answer should be compact. -18.36. In the year 2010, what is the difference between the Gross enrolment ratio (%) of Israel and Gross enrolment ratio (%) of Yemen, Rep.?
Your response must be concise. 12.14. In the year 2010, what is the difference between the Gross enrolment ratio (%) of Vanuatu and Gross enrolment ratio (%) of Yemen, Rep.?
Offer a very short reply. 30.5. In the year 2013, what is the difference between the Gross enrolment ratio (%) of South Asia and Gross enrolment ratio (%) of Israel?
Your answer should be compact. 7.09. In the year 2013, what is the difference between the Gross enrolment ratio (%) in South Asia and Gross enrolment ratio (%) in Vanuatu?
Keep it short and to the point. -11.69. In the year 2013, what is the difference between the Gross enrolment ratio (%) of South Asia and Gross enrolment ratio (%) of Yemen, Rep.?
Your answer should be compact. 10.46. In the year 2013, what is the difference between the Gross enrolment ratio (%) in Israel and Gross enrolment ratio (%) in Vanuatu?
Offer a terse response. -18.78. In the year 2013, what is the difference between the Gross enrolment ratio (%) of Israel and Gross enrolment ratio (%) of Yemen, Rep.?
Provide a succinct answer. 3.37. In the year 2013, what is the difference between the Gross enrolment ratio (%) of Vanuatu and Gross enrolment ratio (%) of Yemen, Rep.?
Your response must be concise. 22.15. What is the ratio of the Gross enrolment ratio (%) of South Asia in 2002 to that in 2003?
Your answer should be compact. 0.93. What is the ratio of the Gross enrolment ratio (%) of Vanuatu in 2002 to that in 2003?
Provide a succinct answer. 0.97. What is the ratio of the Gross enrolment ratio (%) of Yemen, Rep. in 2002 to that in 2003?
Your answer should be compact. 0.96. What is the ratio of the Gross enrolment ratio (%) in South Asia in 2002 to that in 2004?
Provide a succinct answer. 0.91. What is the ratio of the Gross enrolment ratio (%) of Israel in 2002 to that in 2004?
Ensure brevity in your answer.  1.01. What is the ratio of the Gross enrolment ratio (%) in Yemen, Rep. in 2002 to that in 2004?
Provide a short and direct response. 0.93. What is the ratio of the Gross enrolment ratio (%) in South Asia in 2002 to that in 2005?
Your response must be concise. 0.89. What is the ratio of the Gross enrolment ratio (%) of Israel in 2002 to that in 2005?
Make the answer very short. 1.02. What is the ratio of the Gross enrolment ratio (%) in Vanuatu in 2002 to that in 2005?
Your answer should be very brief. 1.03. What is the ratio of the Gross enrolment ratio (%) of Yemen, Rep. in 2002 to that in 2005?
Provide a succinct answer. 0.9. What is the ratio of the Gross enrolment ratio (%) of South Asia in 2002 to that in 2008?
Keep it short and to the point. 0.85. What is the ratio of the Gross enrolment ratio (%) of Israel in 2002 to that in 2008?
Offer a very short reply. 1.03. What is the ratio of the Gross enrolment ratio (%) in Vanuatu in 2002 to that in 2008?
Provide a succinct answer. 1.07. What is the ratio of the Gross enrolment ratio (%) in Yemen, Rep. in 2002 to that in 2008?
Ensure brevity in your answer.  0.9. What is the ratio of the Gross enrolment ratio (%) in South Asia in 2002 to that in 2010?
Keep it short and to the point. 0.85. What is the ratio of the Gross enrolment ratio (%) in Israel in 2002 to that in 2010?
Keep it short and to the point. 1.02. What is the ratio of the Gross enrolment ratio (%) of Yemen, Rep. in 2002 to that in 2010?
Your answer should be compact. 0.88. What is the ratio of the Gross enrolment ratio (%) in South Asia in 2002 to that in 2013?
Your answer should be compact. 0.84. What is the ratio of the Gross enrolment ratio (%) in Israel in 2002 to that in 2013?
Your response must be concise. 1.01. What is the ratio of the Gross enrolment ratio (%) of Vanuatu in 2002 to that in 2013?
Give a very brief answer. 0.99. What is the ratio of the Gross enrolment ratio (%) in Yemen, Rep. in 2002 to that in 2013?
Make the answer very short. 0.8. What is the ratio of the Gross enrolment ratio (%) of South Asia in 2003 to that in 2004?
Offer a very short reply. 0.98. What is the ratio of the Gross enrolment ratio (%) of Vanuatu in 2003 to that in 2004?
Offer a very short reply. 1.03. What is the ratio of the Gross enrolment ratio (%) of South Asia in 2003 to that in 2005?
Your answer should be very brief. 0.96. What is the ratio of the Gross enrolment ratio (%) in Israel in 2003 to that in 2005?
Provide a succinct answer. 1.02. What is the ratio of the Gross enrolment ratio (%) in Vanuatu in 2003 to that in 2005?
Give a very brief answer. 1.06. What is the ratio of the Gross enrolment ratio (%) in Yemen, Rep. in 2003 to that in 2005?
Provide a short and direct response. 0.94. What is the ratio of the Gross enrolment ratio (%) of South Asia in 2003 to that in 2008?
Your answer should be compact. 0.92. What is the ratio of the Gross enrolment ratio (%) of Israel in 2003 to that in 2008?
Your answer should be very brief. 1.03. What is the ratio of the Gross enrolment ratio (%) in Vanuatu in 2003 to that in 2008?
Offer a terse response. 1.1. What is the ratio of the Gross enrolment ratio (%) in Yemen, Rep. in 2003 to that in 2008?
Your response must be concise. 0.93. What is the ratio of the Gross enrolment ratio (%) of South Asia in 2003 to that in 2010?
Provide a short and direct response. 0.91. What is the ratio of the Gross enrolment ratio (%) of Israel in 2003 to that in 2010?
Your answer should be very brief. 1.01. What is the ratio of the Gross enrolment ratio (%) of Vanuatu in 2003 to that in 2010?
Your answer should be compact. 1.02. What is the ratio of the Gross enrolment ratio (%) in South Asia in 2003 to that in 2013?
Your response must be concise. 0.9. What is the ratio of the Gross enrolment ratio (%) of Israel in 2003 to that in 2013?
Your response must be concise. 1.01. What is the ratio of the Gross enrolment ratio (%) of Vanuatu in 2003 to that in 2013?
Offer a very short reply. 1.02. What is the ratio of the Gross enrolment ratio (%) of Yemen, Rep. in 2003 to that in 2013?
Make the answer very short. 0.83. What is the ratio of the Gross enrolment ratio (%) of South Asia in 2004 to that in 2005?
Make the answer very short. 0.98. What is the ratio of the Gross enrolment ratio (%) of Israel in 2004 to that in 2005?
Your answer should be very brief. 1.01. What is the ratio of the Gross enrolment ratio (%) of Vanuatu in 2004 to that in 2005?
Provide a succinct answer. 1.03. What is the ratio of the Gross enrolment ratio (%) in Yemen, Rep. in 2004 to that in 2005?
Provide a short and direct response. 0.97. What is the ratio of the Gross enrolment ratio (%) of South Asia in 2004 to that in 2008?
Ensure brevity in your answer.  0.94. What is the ratio of the Gross enrolment ratio (%) in Vanuatu in 2004 to that in 2008?
Give a very brief answer. 1.06. What is the ratio of the Gross enrolment ratio (%) of Yemen, Rep. in 2004 to that in 2008?
Your answer should be compact. 0.97. What is the ratio of the Gross enrolment ratio (%) in South Asia in 2004 to that in 2010?
Offer a terse response. 0.93. What is the ratio of the Gross enrolment ratio (%) of Israel in 2004 to that in 2010?
Your response must be concise. 1.01. What is the ratio of the Gross enrolment ratio (%) in Yemen, Rep. in 2004 to that in 2010?
Your answer should be compact. 0.94. What is the ratio of the Gross enrolment ratio (%) in South Asia in 2004 to that in 2013?
Keep it short and to the point. 0.93. What is the ratio of the Gross enrolment ratio (%) of Israel in 2004 to that in 2013?
Your answer should be very brief. 1.01. What is the ratio of the Gross enrolment ratio (%) of Vanuatu in 2004 to that in 2013?
Give a very brief answer. 0.98. What is the ratio of the Gross enrolment ratio (%) of Yemen, Rep. in 2004 to that in 2013?
Keep it short and to the point. 0.86. What is the ratio of the Gross enrolment ratio (%) in South Asia in 2005 to that in 2008?
Provide a short and direct response. 0.96. What is the ratio of the Gross enrolment ratio (%) of Israel in 2005 to that in 2008?
Provide a succinct answer. 1.01. What is the ratio of the Gross enrolment ratio (%) of Vanuatu in 2005 to that in 2008?
Provide a succinct answer. 1.03. What is the ratio of the Gross enrolment ratio (%) in South Asia in 2005 to that in 2010?
Offer a terse response. 0.95. What is the ratio of the Gross enrolment ratio (%) in Vanuatu in 2005 to that in 2010?
Your response must be concise. 0.96. What is the ratio of the Gross enrolment ratio (%) in Yemen, Rep. in 2005 to that in 2010?
Provide a short and direct response. 0.97. What is the ratio of the Gross enrolment ratio (%) of South Asia in 2005 to that in 2013?
Make the answer very short. 0.94. What is the ratio of the Gross enrolment ratio (%) of Vanuatu in 2005 to that in 2013?
Your response must be concise. 0.96. What is the ratio of the Gross enrolment ratio (%) in Yemen, Rep. in 2005 to that in 2013?
Keep it short and to the point. 0.88. What is the ratio of the Gross enrolment ratio (%) of South Asia in 2008 to that in 2010?
Provide a succinct answer. 1. What is the ratio of the Gross enrolment ratio (%) of Israel in 2008 to that in 2010?
Offer a very short reply. 0.98. What is the ratio of the Gross enrolment ratio (%) of Vanuatu in 2008 to that in 2010?
Provide a short and direct response. 0.93. What is the ratio of the Gross enrolment ratio (%) in Yemen, Rep. in 2008 to that in 2010?
Provide a succinct answer. 0.98. What is the ratio of the Gross enrolment ratio (%) in Israel in 2008 to that in 2013?
Provide a short and direct response. 0.98. What is the ratio of the Gross enrolment ratio (%) in Vanuatu in 2008 to that in 2013?
Your response must be concise. 0.92. What is the ratio of the Gross enrolment ratio (%) in Yemen, Rep. in 2008 to that in 2013?
Provide a short and direct response. 0.89. What is the ratio of the Gross enrolment ratio (%) of Israel in 2010 to that in 2013?
Offer a very short reply. 1. What is the ratio of the Gross enrolment ratio (%) of Yemen, Rep. in 2010 to that in 2013?
Your answer should be very brief. 0.91. What is the difference between the highest and the second highest Gross enrolment ratio (%) in South Asia?
Provide a short and direct response. 1.11. What is the difference between the highest and the second highest Gross enrolment ratio (%) in Israel?
Make the answer very short. 0.45. What is the difference between the highest and the second highest Gross enrolment ratio (%) of Vanuatu?
Ensure brevity in your answer.  1.97. What is the difference between the highest and the second highest Gross enrolment ratio (%) of Yemen, Rep.?
Make the answer very short. 9.03. What is the difference between the highest and the lowest Gross enrolment ratio (%) in South Asia?
Ensure brevity in your answer.  17.69. What is the difference between the highest and the lowest Gross enrolment ratio (%) of Israel?
Offer a terse response. 3.44. What is the difference between the highest and the lowest Gross enrolment ratio (%) of Vanuatu?
Provide a succinct answer. 11.27. What is the difference between the highest and the lowest Gross enrolment ratio (%) of Yemen, Rep.?
Keep it short and to the point. 20.44. 